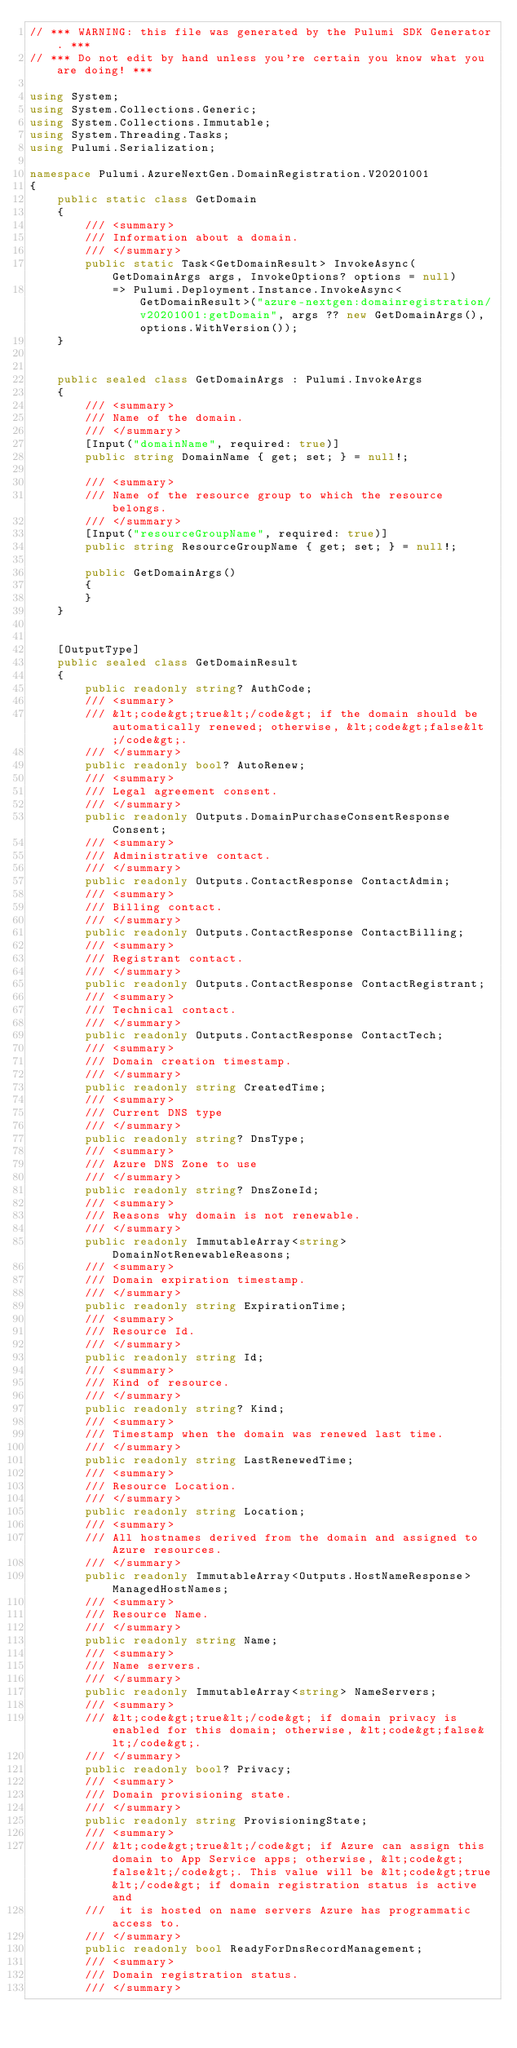Convert code to text. <code><loc_0><loc_0><loc_500><loc_500><_C#_>// *** WARNING: this file was generated by the Pulumi SDK Generator. ***
// *** Do not edit by hand unless you're certain you know what you are doing! ***

using System;
using System.Collections.Generic;
using System.Collections.Immutable;
using System.Threading.Tasks;
using Pulumi.Serialization;

namespace Pulumi.AzureNextGen.DomainRegistration.V20201001
{
    public static class GetDomain
    {
        /// <summary>
        /// Information about a domain.
        /// </summary>
        public static Task<GetDomainResult> InvokeAsync(GetDomainArgs args, InvokeOptions? options = null)
            => Pulumi.Deployment.Instance.InvokeAsync<GetDomainResult>("azure-nextgen:domainregistration/v20201001:getDomain", args ?? new GetDomainArgs(), options.WithVersion());
    }


    public sealed class GetDomainArgs : Pulumi.InvokeArgs
    {
        /// <summary>
        /// Name of the domain.
        /// </summary>
        [Input("domainName", required: true)]
        public string DomainName { get; set; } = null!;

        /// <summary>
        /// Name of the resource group to which the resource belongs.
        /// </summary>
        [Input("resourceGroupName", required: true)]
        public string ResourceGroupName { get; set; } = null!;

        public GetDomainArgs()
        {
        }
    }


    [OutputType]
    public sealed class GetDomainResult
    {
        public readonly string? AuthCode;
        /// <summary>
        /// &lt;code&gt;true&lt;/code&gt; if the domain should be automatically renewed; otherwise, &lt;code&gt;false&lt;/code&gt;.
        /// </summary>
        public readonly bool? AutoRenew;
        /// <summary>
        /// Legal agreement consent.
        /// </summary>
        public readonly Outputs.DomainPurchaseConsentResponse Consent;
        /// <summary>
        /// Administrative contact.
        /// </summary>
        public readonly Outputs.ContactResponse ContactAdmin;
        /// <summary>
        /// Billing contact.
        /// </summary>
        public readonly Outputs.ContactResponse ContactBilling;
        /// <summary>
        /// Registrant contact.
        /// </summary>
        public readonly Outputs.ContactResponse ContactRegistrant;
        /// <summary>
        /// Technical contact.
        /// </summary>
        public readonly Outputs.ContactResponse ContactTech;
        /// <summary>
        /// Domain creation timestamp.
        /// </summary>
        public readonly string CreatedTime;
        /// <summary>
        /// Current DNS type
        /// </summary>
        public readonly string? DnsType;
        /// <summary>
        /// Azure DNS Zone to use
        /// </summary>
        public readonly string? DnsZoneId;
        /// <summary>
        /// Reasons why domain is not renewable.
        /// </summary>
        public readonly ImmutableArray<string> DomainNotRenewableReasons;
        /// <summary>
        /// Domain expiration timestamp.
        /// </summary>
        public readonly string ExpirationTime;
        /// <summary>
        /// Resource Id.
        /// </summary>
        public readonly string Id;
        /// <summary>
        /// Kind of resource.
        /// </summary>
        public readonly string? Kind;
        /// <summary>
        /// Timestamp when the domain was renewed last time.
        /// </summary>
        public readonly string LastRenewedTime;
        /// <summary>
        /// Resource Location.
        /// </summary>
        public readonly string Location;
        /// <summary>
        /// All hostnames derived from the domain and assigned to Azure resources.
        /// </summary>
        public readonly ImmutableArray<Outputs.HostNameResponse> ManagedHostNames;
        /// <summary>
        /// Resource Name.
        /// </summary>
        public readonly string Name;
        /// <summary>
        /// Name servers.
        /// </summary>
        public readonly ImmutableArray<string> NameServers;
        /// <summary>
        /// &lt;code&gt;true&lt;/code&gt; if domain privacy is enabled for this domain; otherwise, &lt;code&gt;false&lt;/code&gt;.
        /// </summary>
        public readonly bool? Privacy;
        /// <summary>
        /// Domain provisioning state.
        /// </summary>
        public readonly string ProvisioningState;
        /// <summary>
        /// &lt;code&gt;true&lt;/code&gt; if Azure can assign this domain to App Service apps; otherwise, &lt;code&gt;false&lt;/code&gt;. This value will be &lt;code&gt;true&lt;/code&gt; if domain registration status is active and 
        ///  it is hosted on name servers Azure has programmatic access to.
        /// </summary>
        public readonly bool ReadyForDnsRecordManagement;
        /// <summary>
        /// Domain registration status.
        /// </summary></code> 